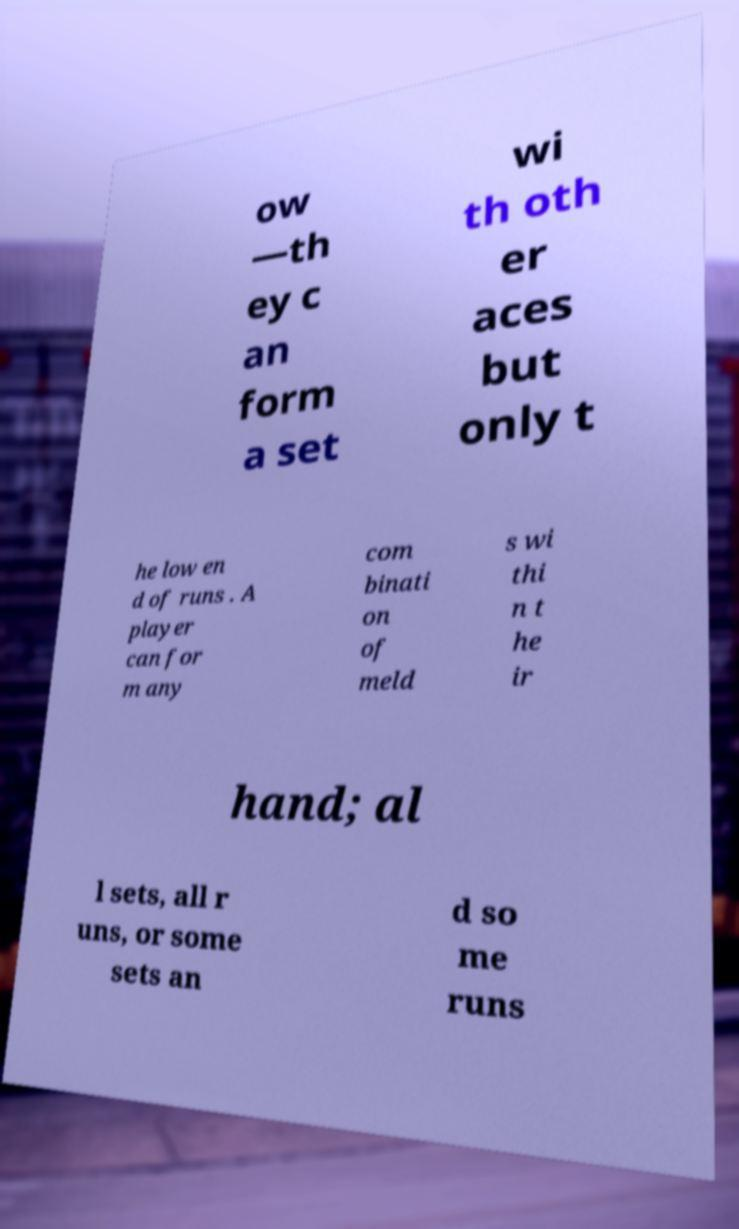What messages or text are displayed in this image? I need them in a readable, typed format. ow —th ey c an form a set wi th oth er aces but only t he low en d of runs . A player can for m any com binati on of meld s wi thi n t he ir hand; al l sets, all r uns, or some sets an d so me runs 